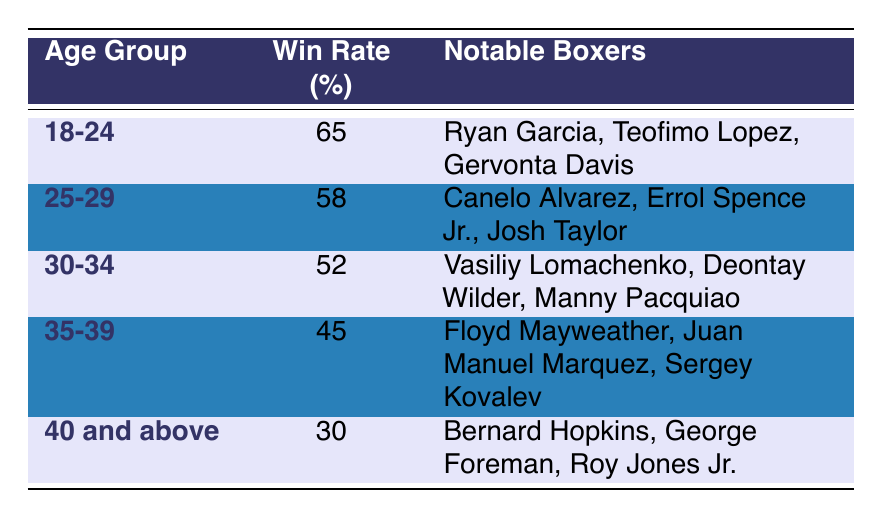What is the win rate for the age group 25-29? The win rate for the age group 25-29 is listed directly in the table as 58.
Answer: 58 Which age group has the highest win rate? Looking at the win rates in the table, the highest value is 65 for the age group 18-24.
Answer: 18-24 What is the win rate difference between age groups 30-34 and 35-39? The win rate for age group 30-34 is 52, and for 35-39 it is 45. The difference is calculated as 52 - 45 = 7.
Answer: 7 Are there any boxers in the age group 40 and above with a win rate higher than 35%? The win rate for the age group 40 and above is 30%, which is lower than 35%. Therefore, there are no boxers in that age group with a win rate higher than 35%.
Answer: No What is the average win rate for the age groups 30-34 and 35-39? The win rates for these age groups are 52 and 45. The average is calculated by adding them: (52 + 45) / 2 = 97 / 2 = 48.5.
Answer: 48.5 Which notable boxer from the age group 18-24 has the highest profile? Among notable boxers in that age group, Ryan Garcia is often considered prominent due to his popularity and performance.
Answer: Ryan Garcia What win rate would a boxer need to be in the top two age groups? The second highest win rate is 58% for the age group 25-29, so to be within the top two, a win rate needs to be at least 58%.
Answer: 58% Are there notable boxers in the age group 35-39? Yes, the table lists Floyd Mayweather, Juan Manuel Marquez, and Sergey Kovalev as notable boxers in that age group.
Answer: Yes What is the win rate for the age group 40 and above, and how does it compare to the age group 30-34? The win rate for 40 and above is 30%, and for 30-34, it is 52%. The comparison shows that 30-34 is 22% higher than 40 and above.
Answer: 22% 